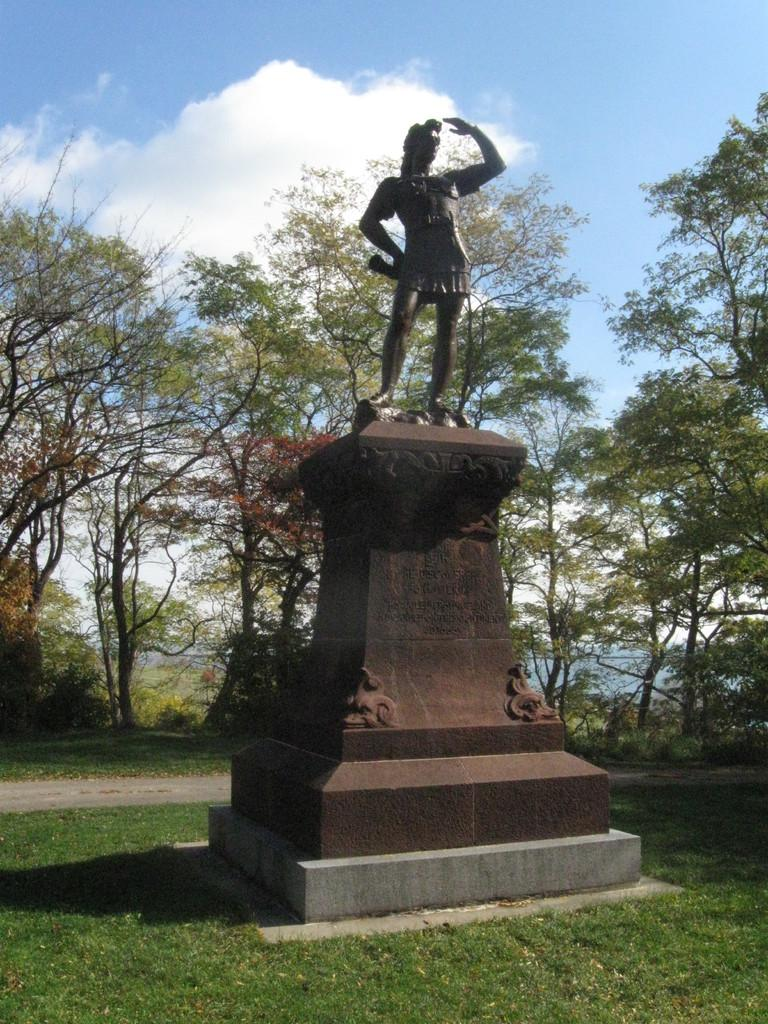What type of terrain is visible in the image? There is an open grass ground in the image. What is located in the front of the image? There is a sculpture in the front of the image. What can be seen in the background of the image? There are trees and clouds visible in the background of the image. What part of the natural environment is visible in the image? The sky is visible in the background of the image. What type of fuel is being used by the sculpture in the image? There is no indication in the image that the sculpture requires fuel, as it is a stationary object. 